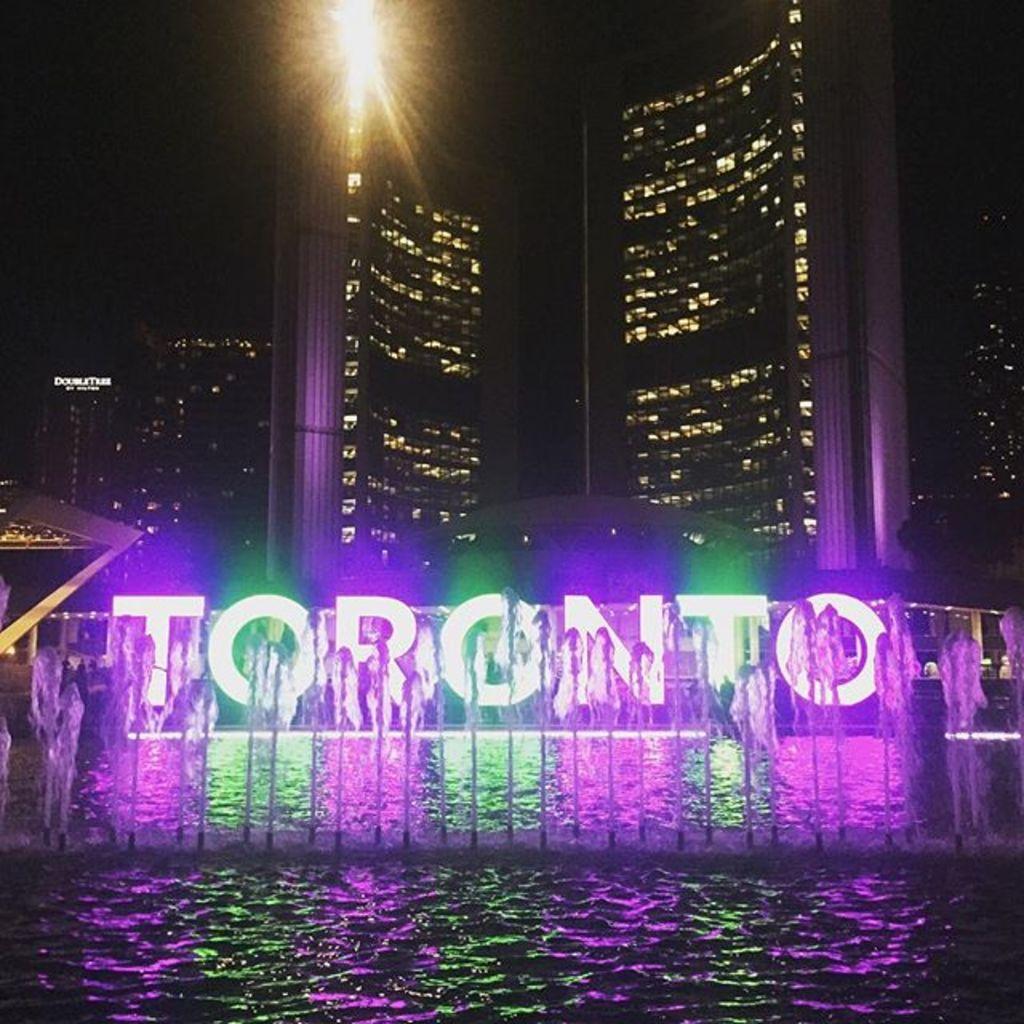Describe this image in one or two sentences. This image consists of water. In the middle, there is a fountain. In the background, there is a building along with lights. It looks like it is clicked in the dark light. 